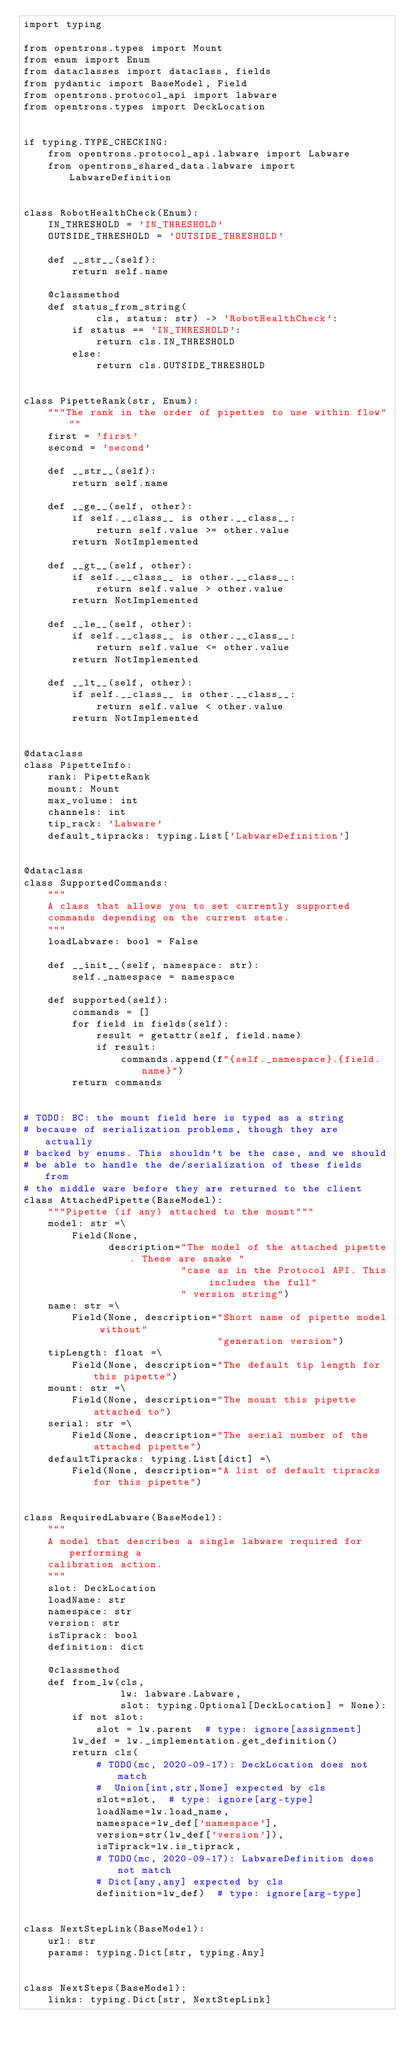<code> <loc_0><loc_0><loc_500><loc_500><_Python_>import typing

from opentrons.types import Mount
from enum import Enum
from dataclasses import dataclass, fields
from pydantic import BaseModel, Field
from opentrons.protocol_api import labware
from opentrons.types import DeckLocation


if typing.TYPE_CHECKING:
    from opentrons.protocol_api.labware import Labware
    from opentrons_shared_data.labware import LabwareDefinition


class RobotHealthCheck(Enum):
    IN_THRESHOLD = 'IN_THRESHOLD'
    OUTSIDE_THRESHOLD = 'OUTSIDE_THRESHOLD'

    def __str__(self):
        return self.name

    @classmethod
    def status_from_string(
            cls, status: str) -> 'RobotHealthCheck':
        if status == 'IN_THRESHOLD':
            return cls.IN_THRESHOLD
        else:
            return cls.OUTSIDE_THRESHOLD


class PipetteRank(str, Enum):
    """The rank in the order of pipettes to use within flow"""
    first = 'first'
    second = 'second'

    def __str__(self):
        return self.name

    def __ge__(self, other):
        if self.__class__ is other.__class__:
            return self.value >= other.value
        return NotImplemented

    def __gt__(self, other):
        if self.__class__ is other.__class__:
            return self.value > other.value
        return NotImplemented

    def __le__(self, other):
        if self.__class__ is other.__class__:
            return self.value <= other.value
        return NotImplemented

    def __lt__(self, other):
        if self.__class__ is other.__class__:
            return self.value < other.value
        return NotImplemented


@dataclass
class PipetteInfo:
    rank: PipetteRank
    mount: Mount
    max_volume: int
    channels: int
    tip_rack: 'Labware'
    default_tipracks: typing.List['LabwareDefinition']


@dataclass
class SupportedCommands:
    """
    A class that allows you to set currently supported
    commands depending on the current state.
    """
    loadLabware: bool = False

    def __init__(self, namespace: str):
        self._namespace = namespace

    def supported(self):
        commands = []
        for field in fields(self):
            result = getattr(self, field.name)
            if result:
                commands.append(f"{self._namespace}.{field.name}")
        return commands


# TODO: BC: the mount field here is typed as a string
# because of serialization problems, though they are actually
# backed by enums. This shouldn't be the case, and we should
# be able to handle the de/serialization of these fields from
# the middle ware before they are returned to the client
class AttachedPipette(BaseModel):
    """Pipette (if any) attached to the mount"""
    model: str =\
        Field(None,
              description="The model of the attached pipette. These are snake "
                          "case as in the Protocol API. This includes the full"
                          " version string")
    name: str =\
        Field(None, description="Short name of pipette model without"
                                "generation version")
    tipLength: float =\
        Field(None, description="The default tip length for this pipette")
    mount: str =\
        Field(None, description="The mount this pipette attached to")
    serial: str =\
        Field(None, description="The serial number of the attached pipette")
    defaultTipracks: typing.List[dict] =\
        Field(None, description="A list of default tipracks for this pipette")


class RequiredLabware(BaseModel):
    """
    A model that describes a single labware required for performing a
    calibration action.
    """
    slot: DeckLocation
    loadName: str
    namespace: str
    version: str
    isTiprack: bool
    definition: dict

    @classmethod
    def from_lw(cls,
                lw: labware.Labware,
                slot: typing.Optional[DeckLocation] = None):
        if not slot:
            slot = lw.parent  # type: ignore[assignment]
        lw_def = lw._implementation.get_definition()
        return cls(
            # TODO(mc, 2020-09-17): DeckLocation does not match
            #  Union[int,str,None] expected by cls
            slot=slot,  # type: ignore[arg-type]
            loadName=lw.load_name,
            namespace=lw_def['namespace'],
            version=str(lw_def['version']),
            isTiprack=lw.is_tiprack,
            # TODO(mc, 2020-09-17): LabwareDefinition does not match
            # Dict[any,any] expected by cls
            definition=lw_def)  # type: ignore[arg-type]


class NextStepLink(BaseModel):
    url: str
    params: typing.Dict[str, typing.Any]


class NextSteps(BaseModel):
    links: typing.Dict[str, NextStepLink]
</code> 